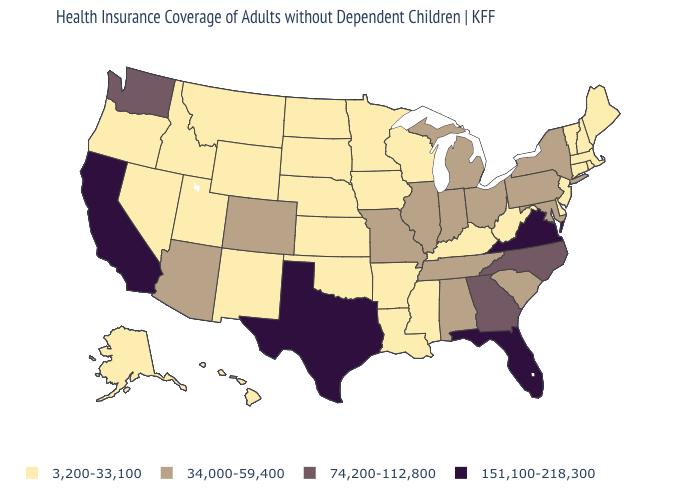What is the highest value in the Northeast ?
Keep it brief. 34,000-59,400. What is the value of Oregon?
Concise answer only. 3,200-33,100. Among the states that border Delaware , which have the lowest value?
Quick response, please. New Jersey. What is the value of Colorado?
Concise answer only. 34,000-59,400. What is the value of Hawaii?
Be succinct. 3,200-33,100. Name the states that have a value in the range 151,100-218,300?
Concise answer only. California, Florida, Texas, Virginia. Which states have the lowest value in the West?
Quick response, please. Alaska, Hawaii, Idaho, Montana, Nevada, New Mexico, Oregon, Utah, Wyoming. Name the states that have a value in the range 74,200-112,800?
Write a very short answer. Georgia, North Carolina, Washington. Name the states that have a value in the range 3,200-33,100?
Give a very brief answer. Alaska, Arkansas, Connecticut, Delaware, Hawaii, Idaho, Iowa, Kansas, Kentucky, Louisiana, Maine, Massachusetts, Minnesota, Mississippi, Montana, Nebraska, Nevada, New Hampshire, New Jersey, New Mexico, North Dakota, Oklahoma, Oregon, Rhode Island, South Dakota, Utah, Vermont, West Virginia, Wisconsin, Wyoming. What is the value of Texas?
Keep it brief. 151,100-218,300. Is the legend a continuous bar?
Quick response, please. No. Does Mississippi have the lowest value in the South?
Give a very brief answer. Yes. Name the states that have a value in the range 34,000-59,400?
Answer briefly. Alabama, Arizona, Colorado, Illinois, Indiana, Maryland, Michigan, Missouri, New York, Ohio, Pennsylvania, South Carolina, Tennessee. Among the states that border Idaho , which have the lowest value?
Concise answer only. Montana, Nevada, Oregon, Utah, Wyoming. Name the states that have a value in the range 3,200-33,100?
Quick response, please. Alaska, Arkansas, Connecticut, Delaware, Hawaii, Idaho, Iowa, Kansas, Kentucky, Louisiana, Maine, Massachusetts, Minnesota, Mississippi, Montana, Nebraska, Nevada, New Hampshire, New Jersey, New Mexico, North Dakota, Oklahoma, Oregon, Rhode Island, South Dakota, Utah, Vermont, West Virginia, Wisconsin, Wyoming. 